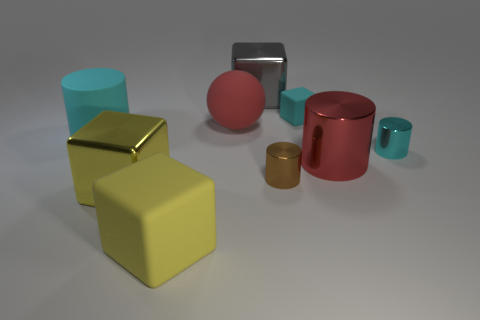Is the shape of the large gray thing the same as the yellow metal thing?
Keep it short and to the point. Yes. What number of brown objects are the same shape as the small cyan matte object?
Your answer should be very brief. 0. There is a matte block behind the small cyan object in front of the cyan rubber cylinder; how big is it?
Provide a short and direct response. Small. There is a shiny thing that is on the left side of the big red ball; does it have the same color as the rubber cube that is left of the gray block?
Ensure brevity in your answer.  Yes. There is a small metal thing that is left of the small cyan object behind the big matte cylinder; what number of red rubber spheres are to the left of it?
Your answer should be very brief. 1. What number of cyan rubber things are on the right side of the brown metal object and to the left of the large yellow matte thing?
Offer a terse response. 0. Is the number of things that are to the right of the cyan matte block greater than the number of yellow matte objects?
Keep it short and to the point. Yes. What number of cyan rubber objects are the same size as the red metallic thing?
Keep it short and to the point. 1. What is the size of the metal object that is the same color as the rubber ball?
Offer a terse response. Large. What number of big things are brown metallic cubes or cyan metallic objects?
Your response must be concise. 0. 